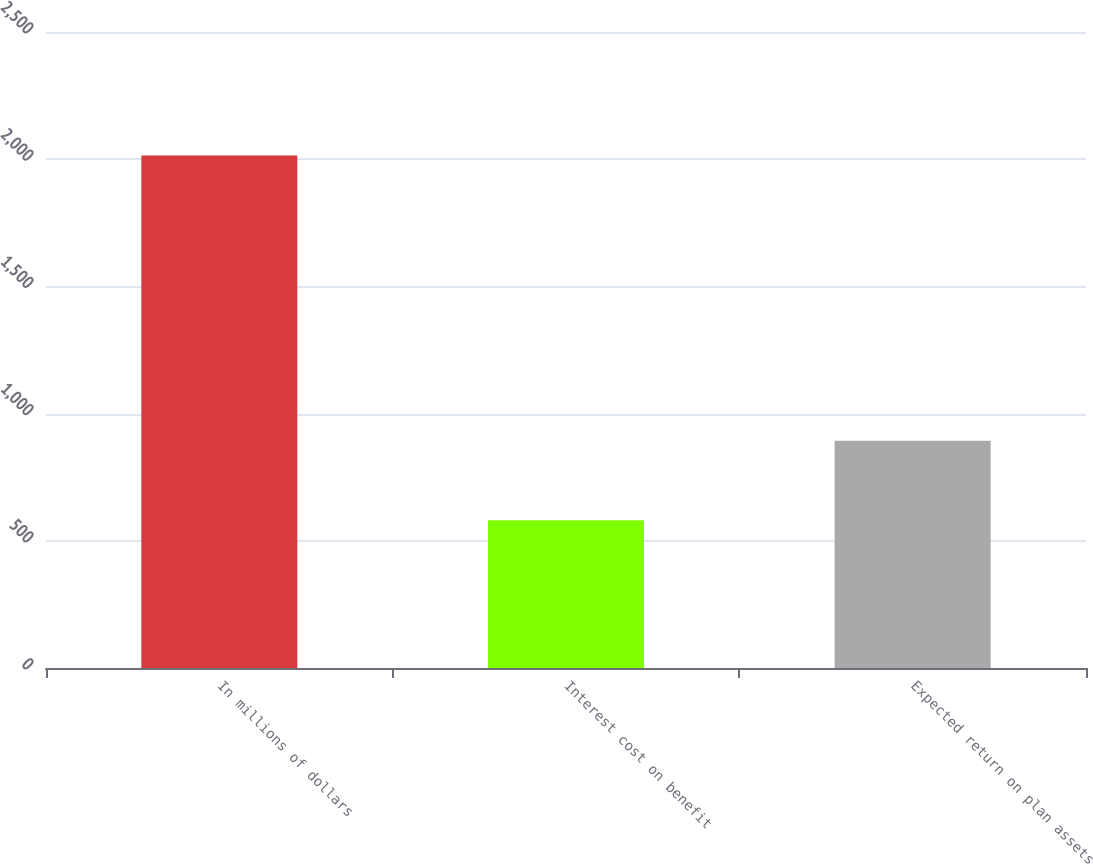Convert chart. <chart><loc_0><loc_0><loc_500><loc_500><bar_chart><fcel>In millions of dollars<fcel>Interest cost on benefit<fcel>Expected return on plan assets<nl><fcel>2015<fcel>581<fcel>893<nl></chart> 